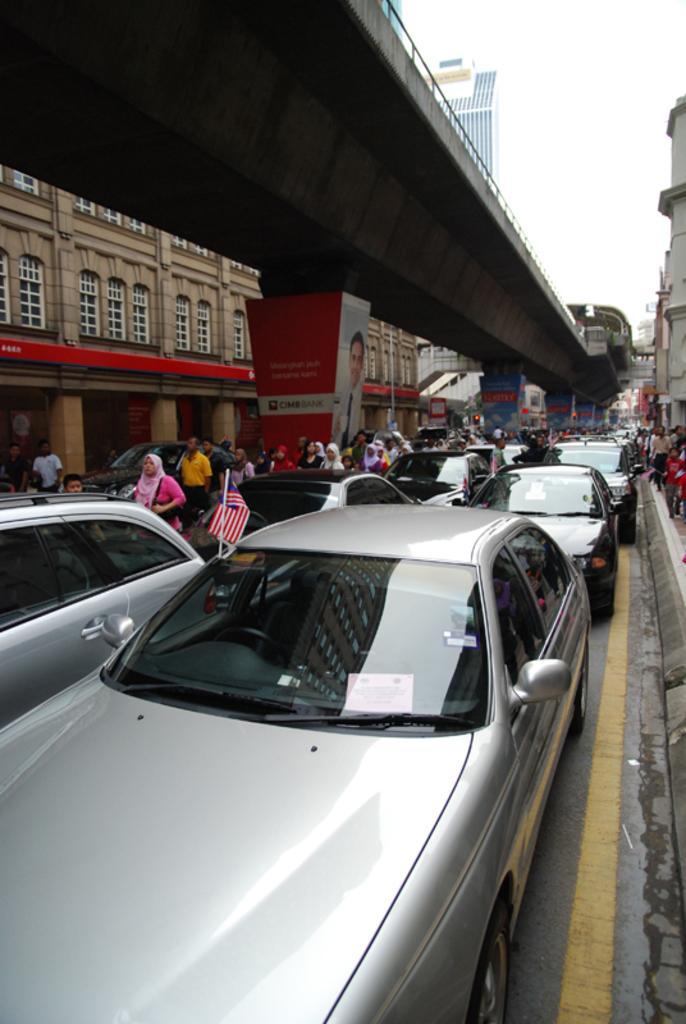Please provide a concise description of this image. In this picture there are vehicles stuck in traffic here and there is a bridge here. There are few people walking on the road and the sky is clear. 